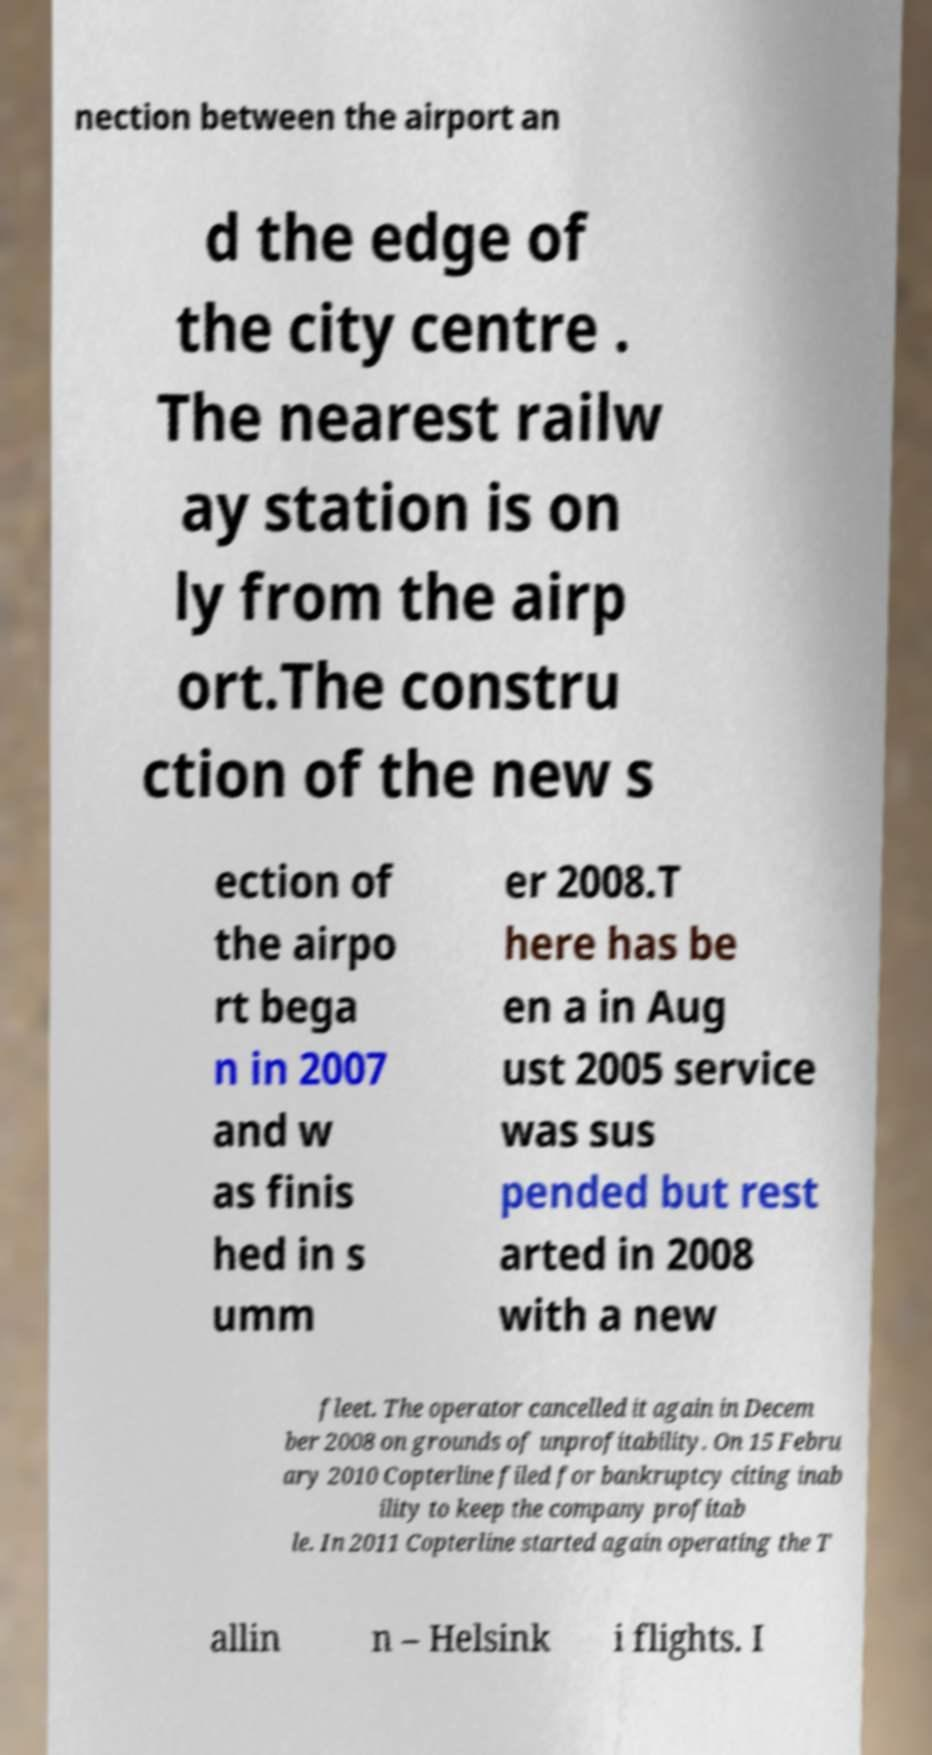There's text embedded in this image that I need extracted. Can you transcribe it verbatim? nection between the airport an d the edge of the city centre . The nearest railw ay station is on ly from the airp ort.The constru ction of the new s ection of the airpo rt bega n in 2007 and w as finis hed in s umm er 2008.T here has be en a in Aug ust 2005 service was sus pended but rest arted in 2008 with a new fleet. The operator cancelled it again in Decem ber 2008 on grounds of unprofitability. On 15 Febru ary 2010 Copterline filed for bankruptcy citing inab ility to keep the company profitab le. In 2011 Copterline started again operating the T allin n – Helsink i flights. I 